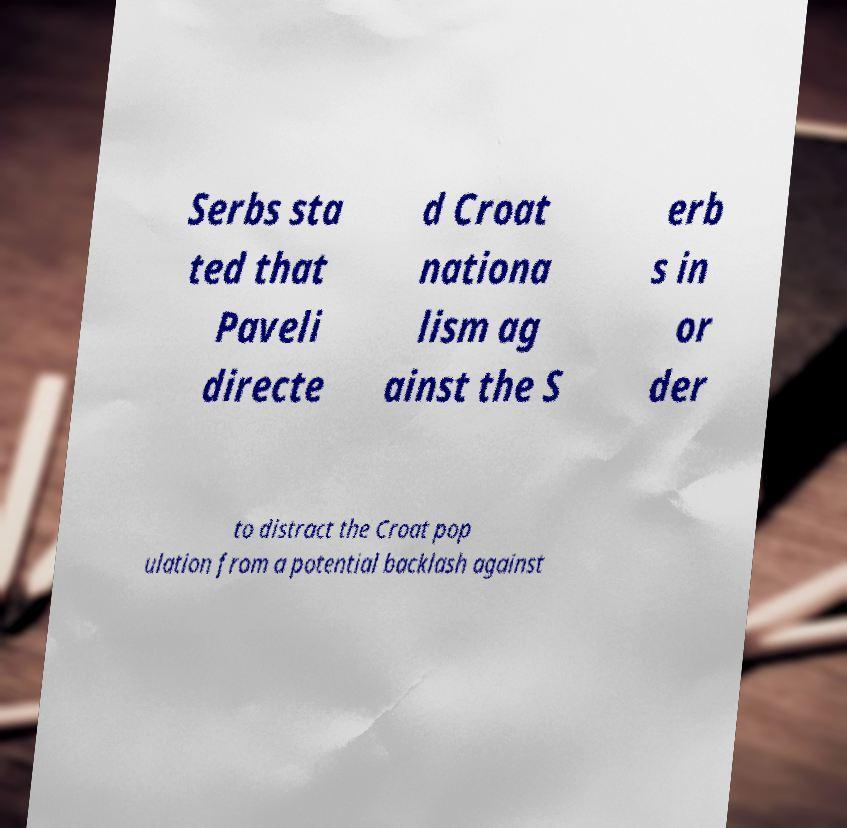I need the written content from this picture converted into text. Can you do that? Serbs sta ted that Paveli directe d Croat nationa lism ag ainst the S erb s in or der to distract the Croat pop ulation from a potential backlash against 